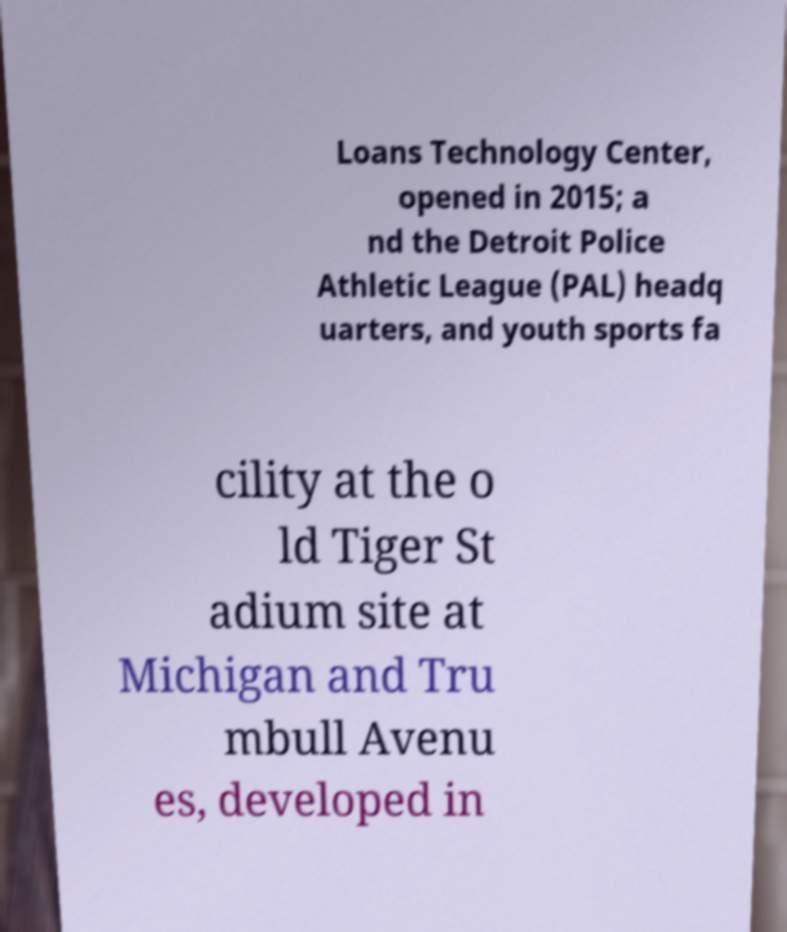Can you accurately transcribe the text from the provided image for me? Loans Technology Center, opened in 2015; a nd the Detroit Police Athletic League (PAL) headq uarters, and youth sports fa cility at the o ld Tiger St adium site at Michigan and Tru mbull Avenu es, developed in 